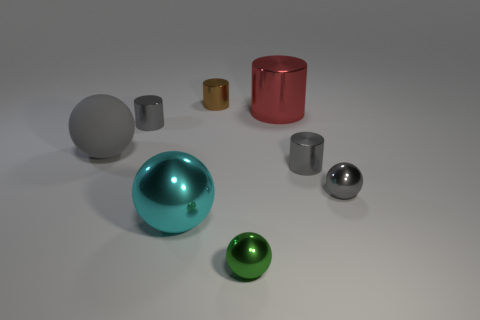Add 1 blue metallic objects. How many objects exist? 9 Add 3 tiny gray spheres. How many tiny gray spheres are left? 4 Add 4 big cyan shiny things. How many big cyan shiny things exist? 5 Subtract 0 blue cylinders. How many objects are left? 8 Subtract all brown shiny cylinders. Subtract all gray metal cylinders. How many objects are left? 5 